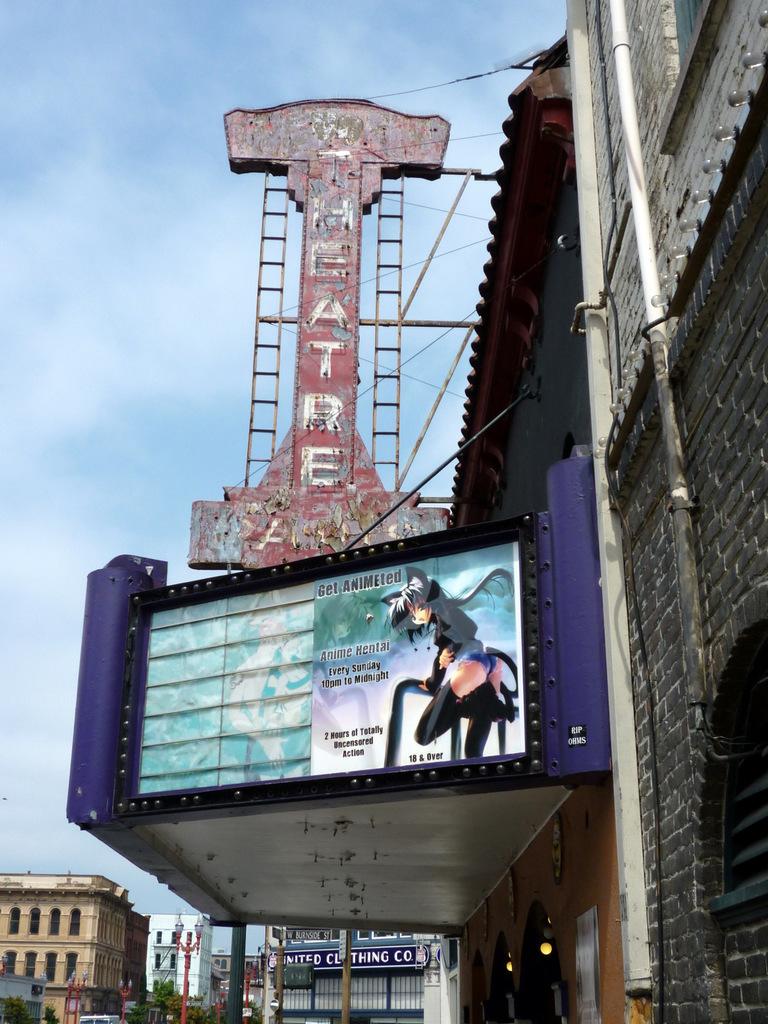What type of cartoon is this?
Ensure brevity in your answer.  Anime. 